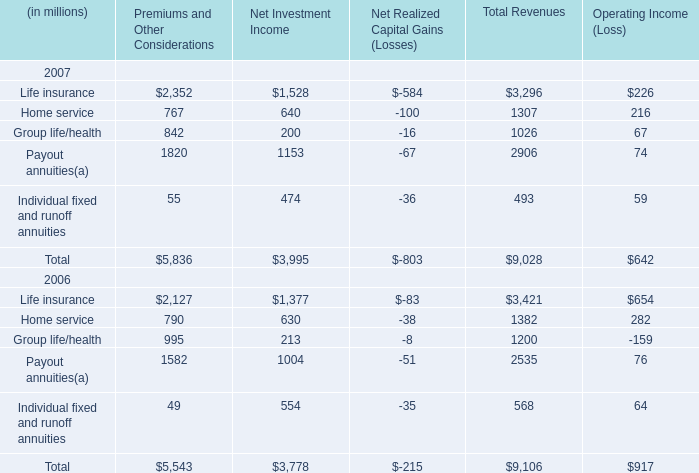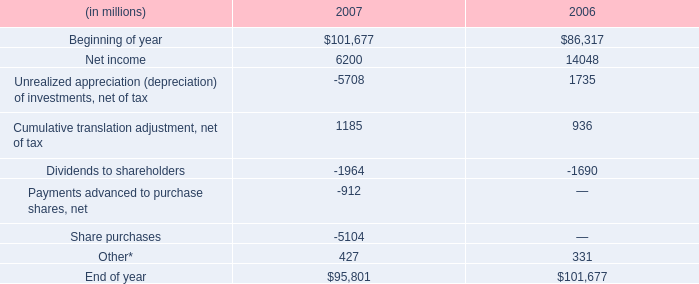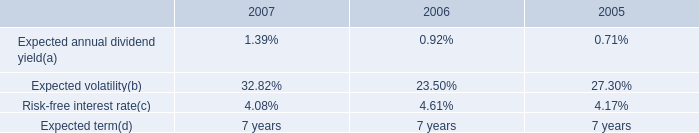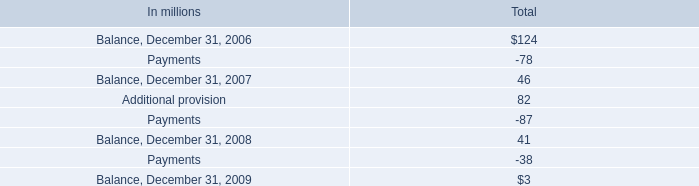Which year / section is Home service in Total Revenues the lowest? 
Answer: 2007. 